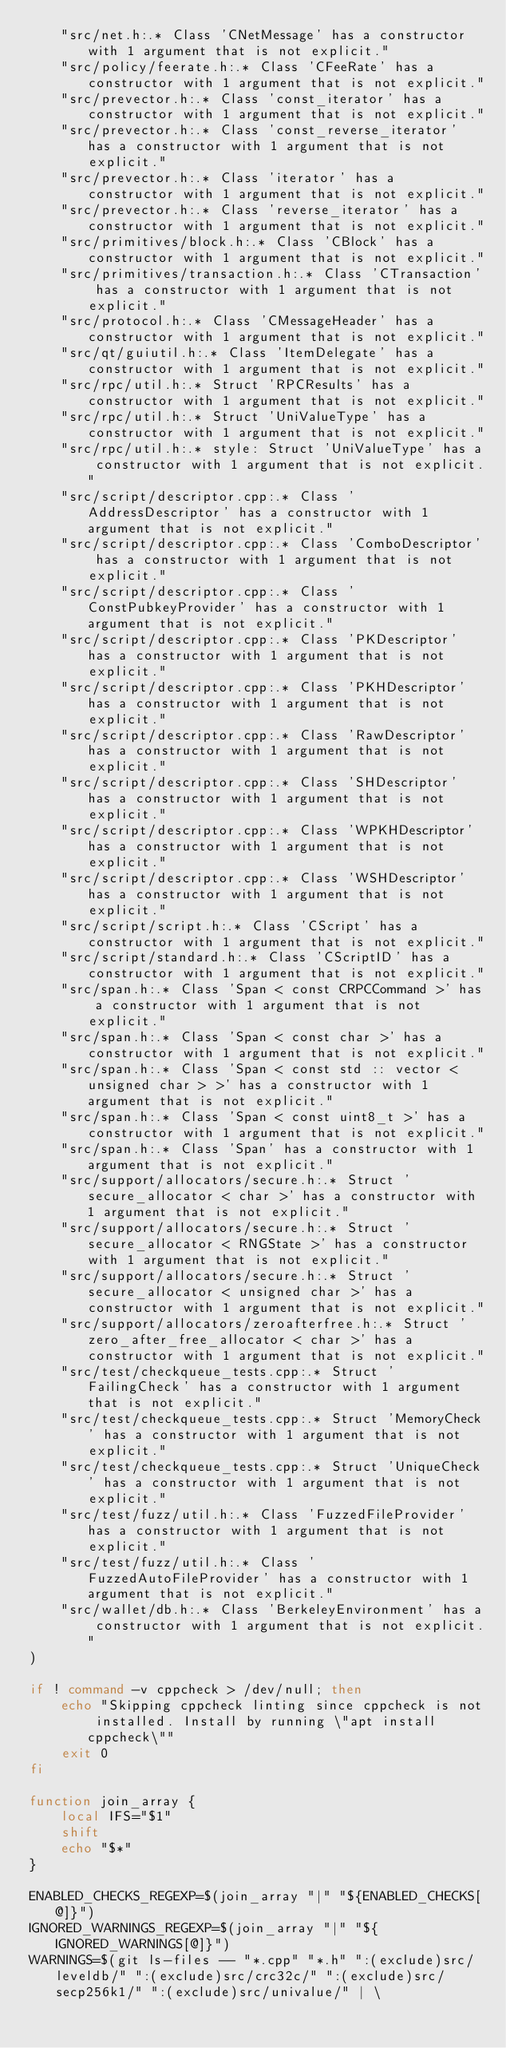<code> <loc_0><loc_0><loc_500><loc_500><_Bash_>    "src/net.h:.* Class 'CNetMessage' has a constructor with 1 argument that is not explicit."
    "src/policy/feerate.h:.* Class 'CFeeRate' has a constructor with 1 argument that is not explicit."
    "src/prevector.h:.* Class 'const_iterator' has a constructor with 1 argument that is not explicit."
    "src/prevector.h:.* Class 'const_reverse_iterator' has a constructor with 1 argument that is not explicit."
    "src/prevector.h:.* Class 'iterator' has a constructor with 1 argument that is not explicit."
    "src/prevector.h:.* Class 'reverse_iterator' has a constructor with 1 argument that is not explicit."
    "src/primitives/block.h:.* Class 'CBlock' has a constructor with 1 argument that is not explicit."
    "src/primitives/transaction.h:.* Class 'CTransaction' has a constructor with 1 argument that is not explicit."
    "src/protocol.h:.* Class 'CMessageHeader' has a constructor with 1 argument that is not explicit."
    "src/qt/guiutil.h:.* Class 'ItemDelegate' has a constructor with 1 argument that is not explicit."
    "src/rpc/util.h:.* Struct 'RPCResults' has a constructor with 1 argument that is not explicit."
    "src/rpc/util.h:.* Struct 'UniValueType' has a constructor with 1 argument that is not explicit."
    "src/rpc/util.h:.* style: Struct 'UniValueType' has a constructor with 1 argument that is not explicit."
    "src/script/descriptor.cpp:.* Class 'AddressDescriptor' has a constructor with 1 argument that is not explicit."
    "src/script/descriptor.cpp:.* Class 'ComboDescriptor' has a constructor with 1 argument that is not explicit."
    "src/script/descriptor.cpp:.* Class 'ConstPubkeyProvider' has a constructor with 1 argument that is not explicit."
    "src/script/descriptor.cpp:.* Class 'PKDescriptor' has a constructor with 1 argument that is not explicit."
    "src/script/descriptor.cpp:.* Class 'PKHDescriptor' has a constructor with 1 argument that is not explicit."
    "src/script/descriptor.cpp:.* Class 'RawDescriptor' has a constructor with 1 argument that is not explicit."
    "src/script/descriptor.cpp:.* Class 'SHDescriptor' has a constructor with 1 argument that is not explicit."
    "src/script/descriptor.cpp:.* Class 'WPKHDescriptor' has a constructor with 1 argument that is not explicit."
    "src/script/descriptor.cpp:.* Class 'WSHDescriptor' has a constructor with 1 argument that is not explicit."
    "src/script/script.h:.* Class 'CScript' has a constructor with 1 argument that is not explicit."
    "src/script/standard.h:.* Class 'CScriptID' has a constructor with 1 argument that is not explicit."
    "src/span.h:.* Class 'Span < const CRPCCommand >' has a constructor with 1 argument that is not explicit."
    "src/span.h:.* Class 'Span < const char >' has a constructor with 1 argument that is not explicit."
    "src/span.h:.* Class 'Span < const std :: vector <unsigned char > >' has a constructor with 1 argument that is not explicit."
    "src/span.h:.* Class 'Span < const uint8_t >' has a constructor with 1 argument that is not explicit."
    "src/span.h:.* Class 'Span' has a constructor with 1 argument that is not explicit."
    "src/support/allocators/secure.h:.* Struct 'secure_allocator < char >' has a constructor with 1 argument that is not explicit."
    "src/support/allocators/secure.h:.* Struct 'secure_allocator < RNGState >' has a constructor with 1 argument that is not explicit."
    "src/support/allocators/secure.h:.* Struct 'secure_allocator < unsigned char >' has a constructor with 1 argument that is not explicit."
    "src/support/allocators/zeroafterfree.h:.* Struct 'zero_after_free_allocator < char >' has a constructor with 1 argument that is not explicit."
    "src/test/checkqueue_tests.cpp:.* Struct 'FailingCheck' has a constructor with 1 argument that is not explicit."
    "src/test/checkqueue_tests.cpp:.* Struct 'MemoryCheck' has a constructor with 1 argument that is not explicit."
    "src/test/checkqueue_tests.cpp:.* Struct 'UniqueCheck' has a constructor with 1 argument that is not explicit."
    "src/test/fuzz/util.h:.* Class 'FuzzedFileProvider' has a constructor with 1 argument that is not explicit."
    "src/test/fuzz/util.h:.* Class 'FuzzedAutoFileProvider' has a constructor with 1 argument that is not explicit."
    "src/wallet/db.h:.* Class 'BerkeleyEnvironment' has a constructor with 1 argument that is not explicit."
)

if ! command -v cppcheck > /dev/null; then
    echo "Skipping cppcheck linting since cppcheck is not installed. Install by running \"apt install cppcheck\""
    exit 0
fi

function join_array {
    local IFS="$1"
    shift
    echo "$*"
}

ENABLED_CHECKS_REGEXP=$(join_array "|" "${ENABLED_CHECKS[@]}")
IGNORED_WARNINGS_REGEXP=$(join_array "|" "${IGNORED_WARNINGS[@]}")
WARNINGS=$(git ls-files -- "*.cpp" "*.h" ":(exclude)src/leveldb/" ":(exclude)src/crc32c/" ":(exclude)src/secp256k1/" ":(exclude)src/univalue/" | \</code> 